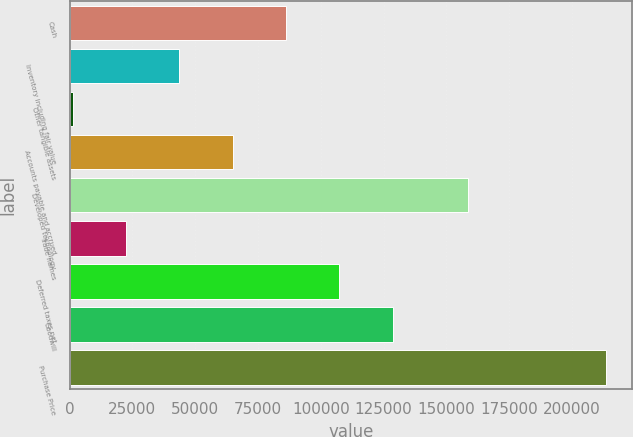<chart> <loc_0><loc_0><loc_500><loc_500><bar_chart><fcel>Cash<fcel>Inventory including fair value<fcel>Other tangible assets<fcel>Accounts payable and accrued<fcel>Developed technology<fcel>Trade names<fcel>Deferred taxes net<fcel>Goodwill<fcel>Purchase Price<nl><fcel>86133.8<fcel>43712.4<fcel>1291<fcel>64923.1<fcel>158741<fcel>22501.7<fcel>107344<fcel>128555<fcel>213398<nl></chart> 